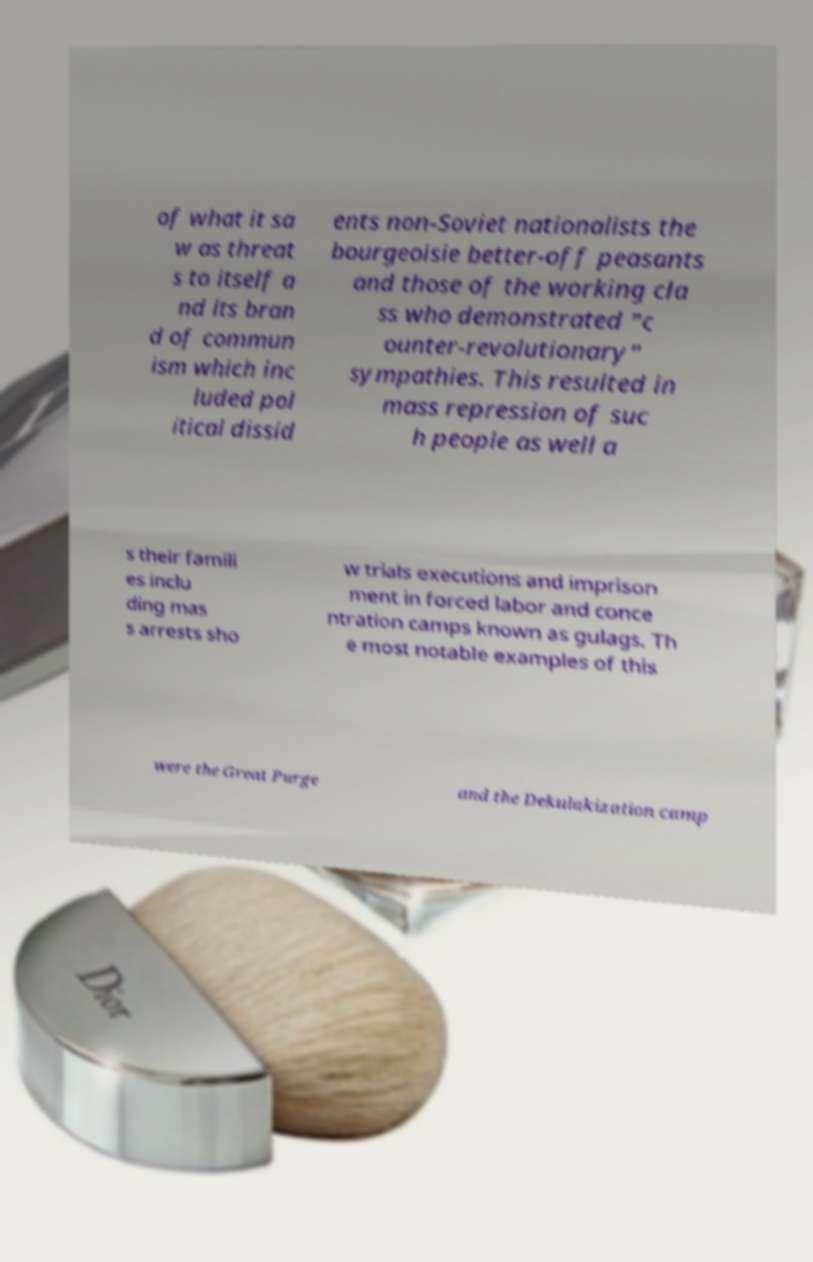I need the written content from this picture converted into text. Can you do that? of what it sa w as threat s to itself a nd its bran d of commun ism which inc luded pol itical dissid ents non-Soviet nationalists the bourgeoisie better-off peasants and those of the working cla ss who demonstrated "c ounter-revolutionary" sympathies. This resulted in mass repression of suc h people as well a s their famili es inclu ding mas s arrests sho w trials executions and imprison ment in forced labor and conce ntration camps known as gulags. Th e most notable examples of this were the Great Purge and the Dekulakization camp 